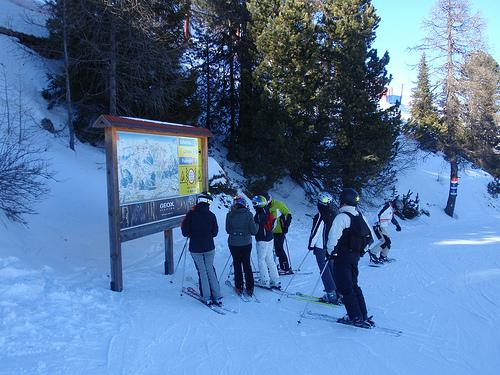Question: why are they reading?
Choices:
A. For enjoyment.
B. For a school assignment.
C. For directions.
D. For knowledge.
Answer with the letter. Answer: C Question: where is the sign?
Choices:
A. Near the people.
B. At the corner.
C. On the pole.
D. Beside the door.
Answer with the letter. Answer: A Question: who is on the snow?
Choices:
A. People.
B. Sledders.
C. Skiers.
D. Snowboarders.
Answer with the letter. Answer: A 